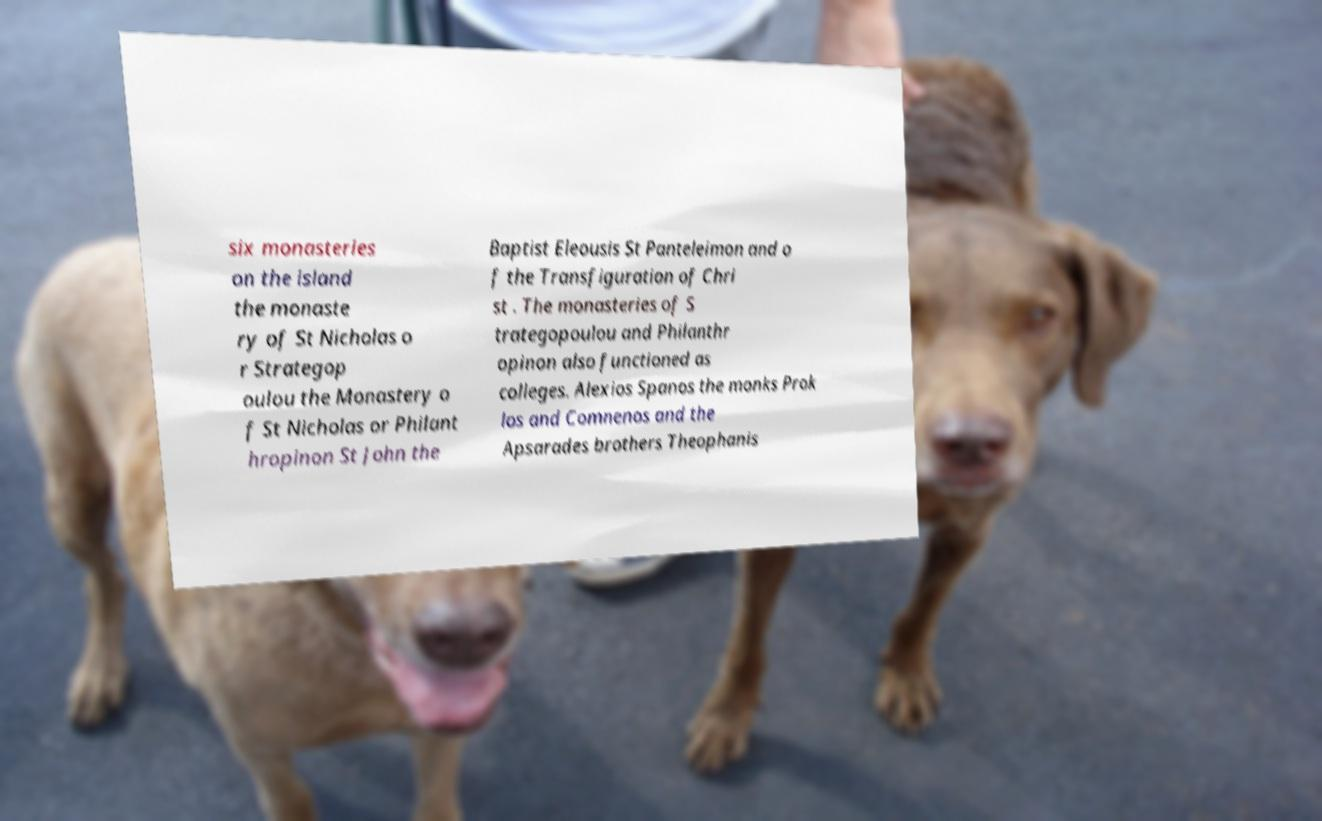Could you extract and type out the text from this image? six monasteries on the island the monaste ry of St Nicholas o r Strategop oulou the Monastery o f St Nicholas or Philant hropinon St John the Baptist Eleousis St Panteleimon and o f the Transfiguration of Chri st . The monasteries of S trategopoulou and Philanthr opinon also functioned as colleges. Alexios Spanos the monks Prok los and Comnenos and the Apsarades brothers Theophanis 